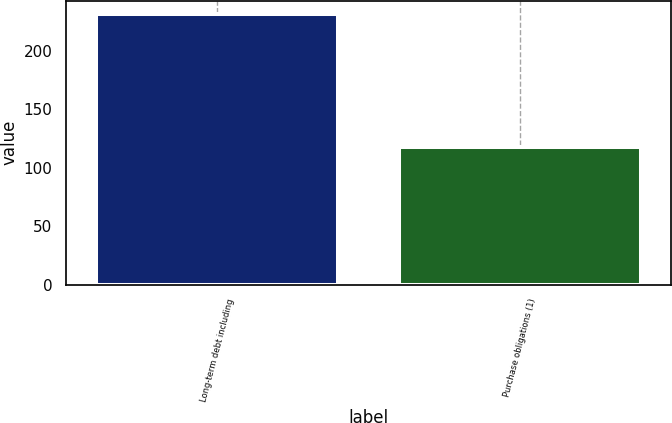Convert chart. <chart><loc_0><loc_0><loc_500><loc_500><bar_chart><fcel>Long-term debt including<fcel>Purchase obligations (1)<nl><fcel>231<fcel>118<nl></chart> 